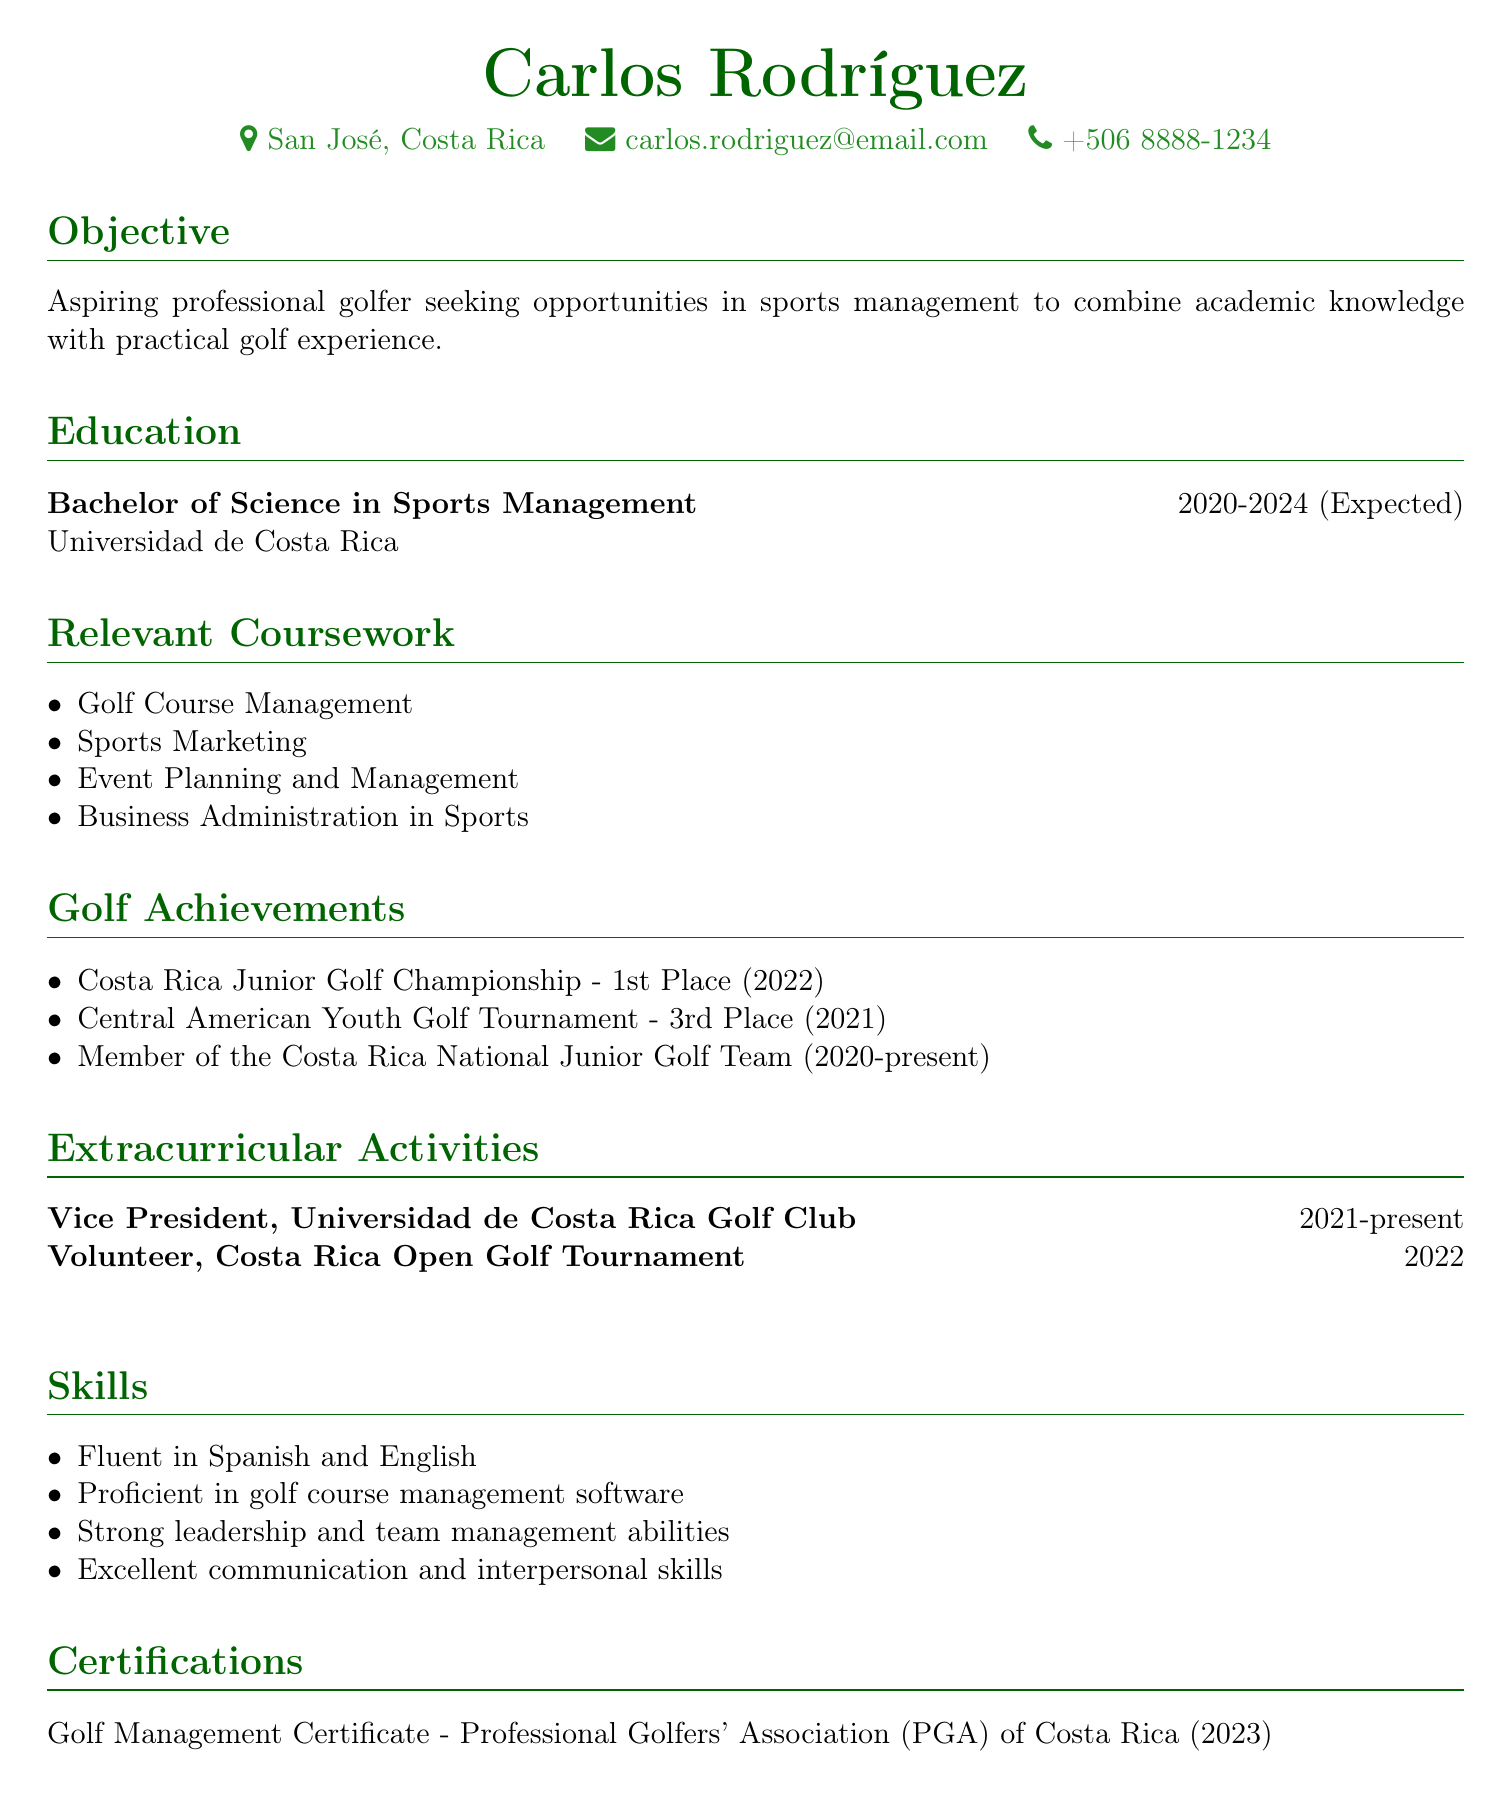What is Carlos Rodríguez's degree? The degree is listed under the Education section of the document, which is a Bachelor of Science in Sports Management.
Answer: Bachelor of Science in Sports Management In what year did Carlos achieve 1st place in the Costa Rica Junior Golf Championship? The achievement is noted in the Golf Achievements section, specifically indicating the year of the event.
Answer: 2022 What is the name of the organization where Carlos is Vice President? The organization is listed in the Extracurricular Activities section under the position of Vice President, which is the Universidad de Costa Rica Golf Club.
Answer: Universidad de Costa Rica Golf Club What language proficiency does Carlos have besides Spanish? The Skills section mentions fluency in multiple languages, including a second language.
Answer: English How long is Carlos expected to complete his degree? The duration of the degree program is stated in the Education section, indicating the start and expected completion year.
Answer: 2020-2024 (Expected) What certification did Carlos receive in 2023? The certification is noted in the Certifications section and provides specific details about the issuing organization and the certification itself.
Answer: Golf Management Certificate - Professional Golfers' Association (PGA) of Costa Rica Which tournament did Carlos volunteer for in 2022? The Volunteer experience is documented in the Extracurricular Activities section, specifying the name of the tournament for which he volunteered.
Answer: Costa Rica Open Golf Tournament How many places did Carlos finish in the Central American Youth Golf Tournament? The placement is mentioned in the Golf Achievements section as a specific result in that tournament.
Answer: 3rd Place What is Carlos's objective in pursuing sports management? The objective states his aspirations and career goals related to sports management and his experience in golf.
Answer: Combine academic knowledge with practical golf experience 